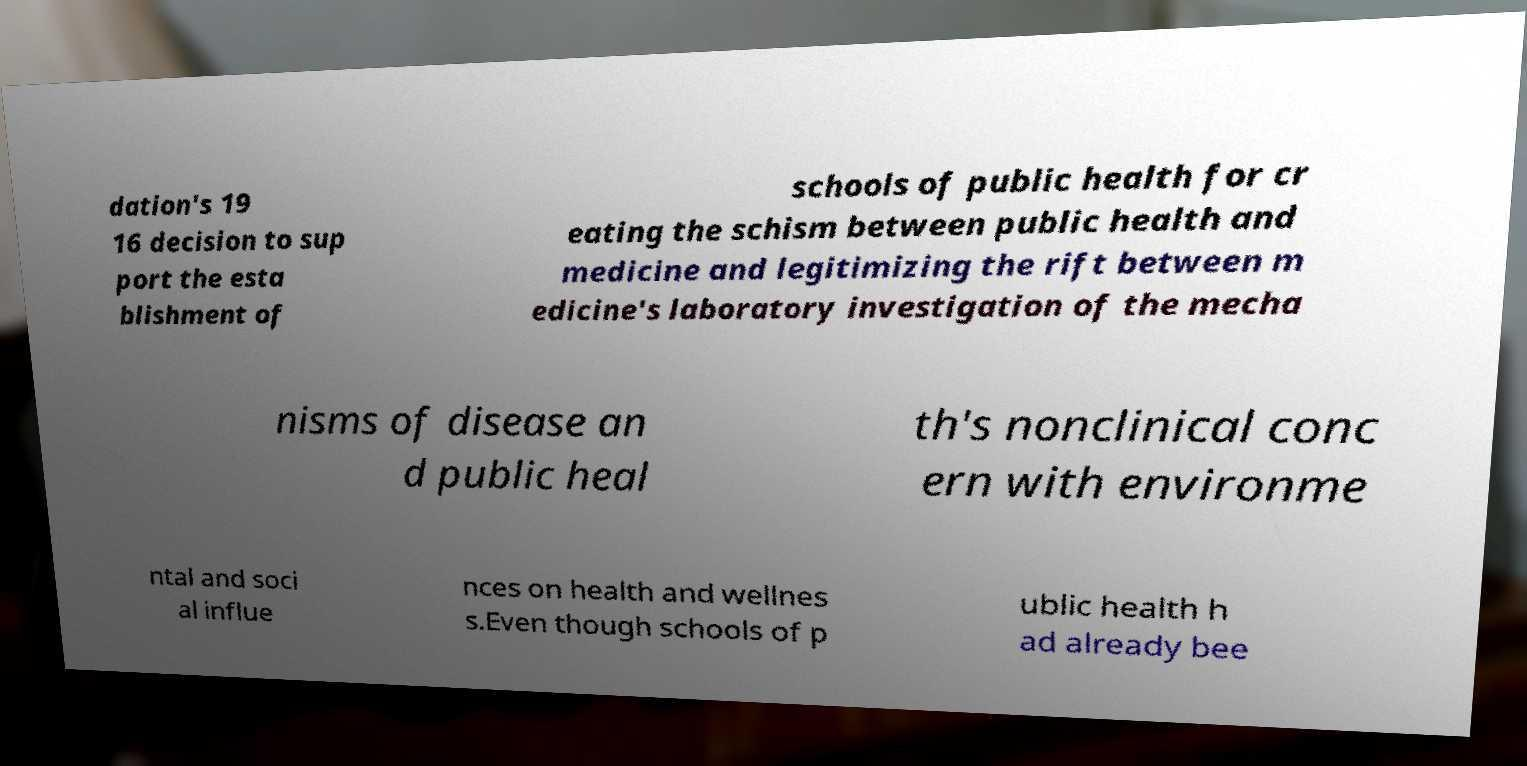Can you accurately transcribe the text from the provided image for me? dation's 19 16 decision to sup port the esta blishment of schools of public health for cr eating the schism between public health and medicine and legitimizing the rift between m edicine's laboratory investigation of the mecha nisms of disease an d public heal th's nonclinical conc ern with environme ntal and soci al influe nces on health and wellnes s.Even though schools of p ublic health h ad already bee 